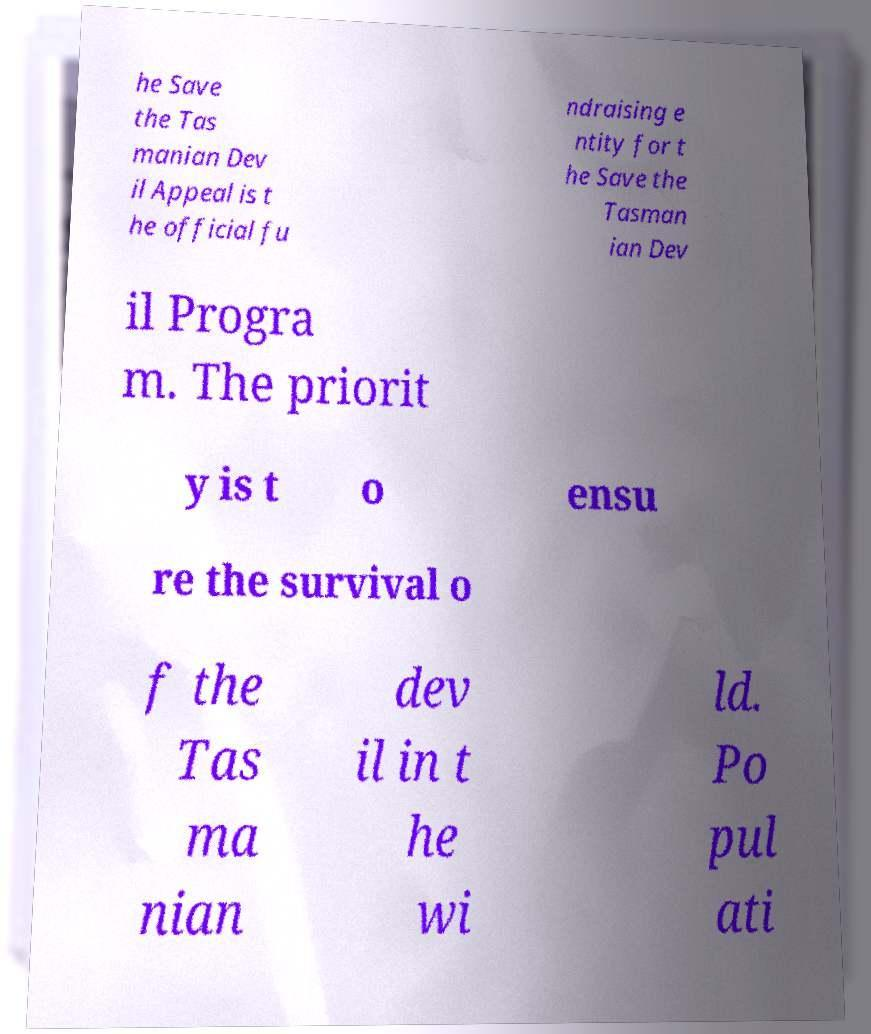Can you read and provide the text displayed in the image?This photo seems to have some interesting text. Can you extract and type it out for me? he Save the Tas manian Dev il Appeal is t he official fu ndraising e ntity for t he Save the Tasman ian Dev il Progra m. The priorit y is t o ensu re the survival o f the Tas ma nian dev il in t he wi ld. Po pul ati 